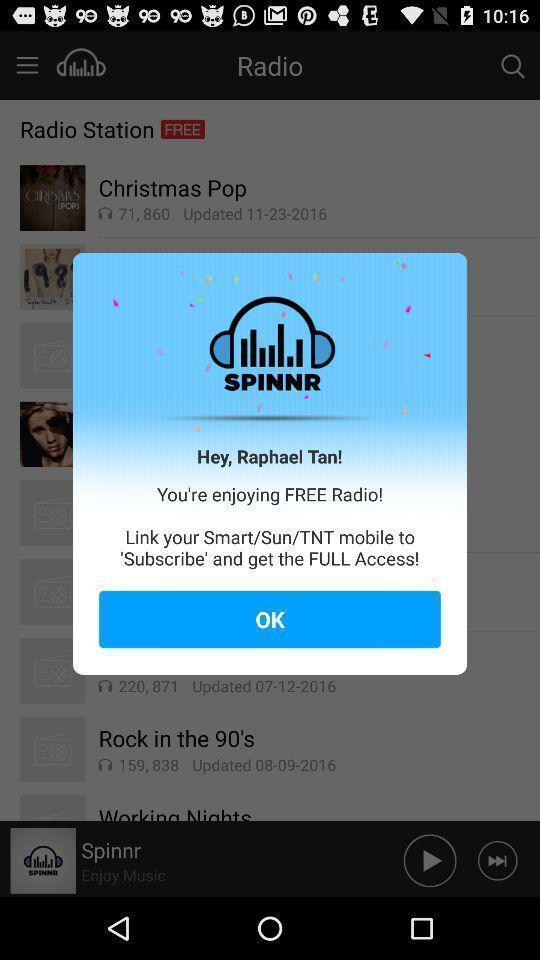Summarize the information in this screenshot. Pop-up asking are you enjoying using the app. 